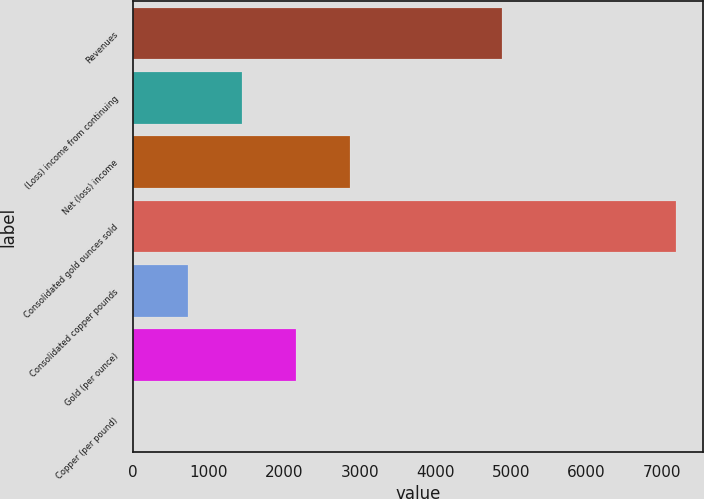Convert chart to OTSL. <chart><loc_0><loc_0><loc_500><loc_500><bar_chart><fcel>Revenues<fcel>(Loss) income from continuing<fcel>Net (loss) income<fcel>Consolidated gold ounces sold<fcel>Consolidated copper pounds<fcel>Gold (per ounce)<fcel>Copper (per pound)<nl><fcel>4882<fcel>1438.44<fcel>2875.34<fcel>7186<fcel>719.99<fcel>2156.89<fcel>1.54<nl></chart> 